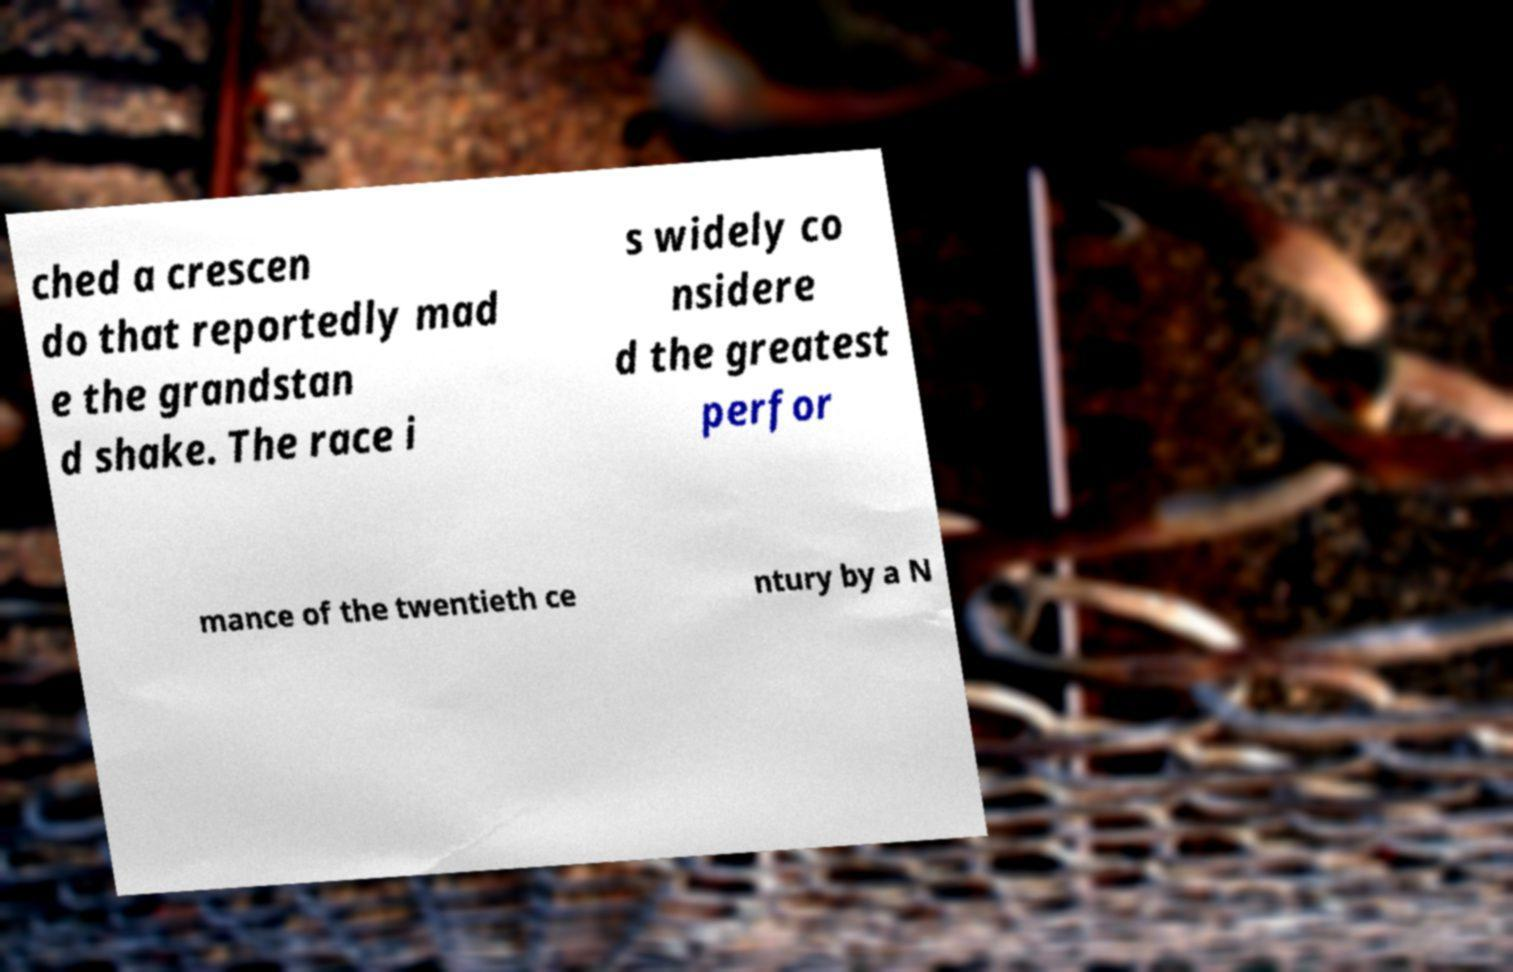Could you assist in decoding the text presented in this image and type it out clearly? ched a crescen do that reportedly mad e the grandstan d shake. The race i s widely co nsidere d the greatest perfor mance of the twentieth ce ntury by a N 